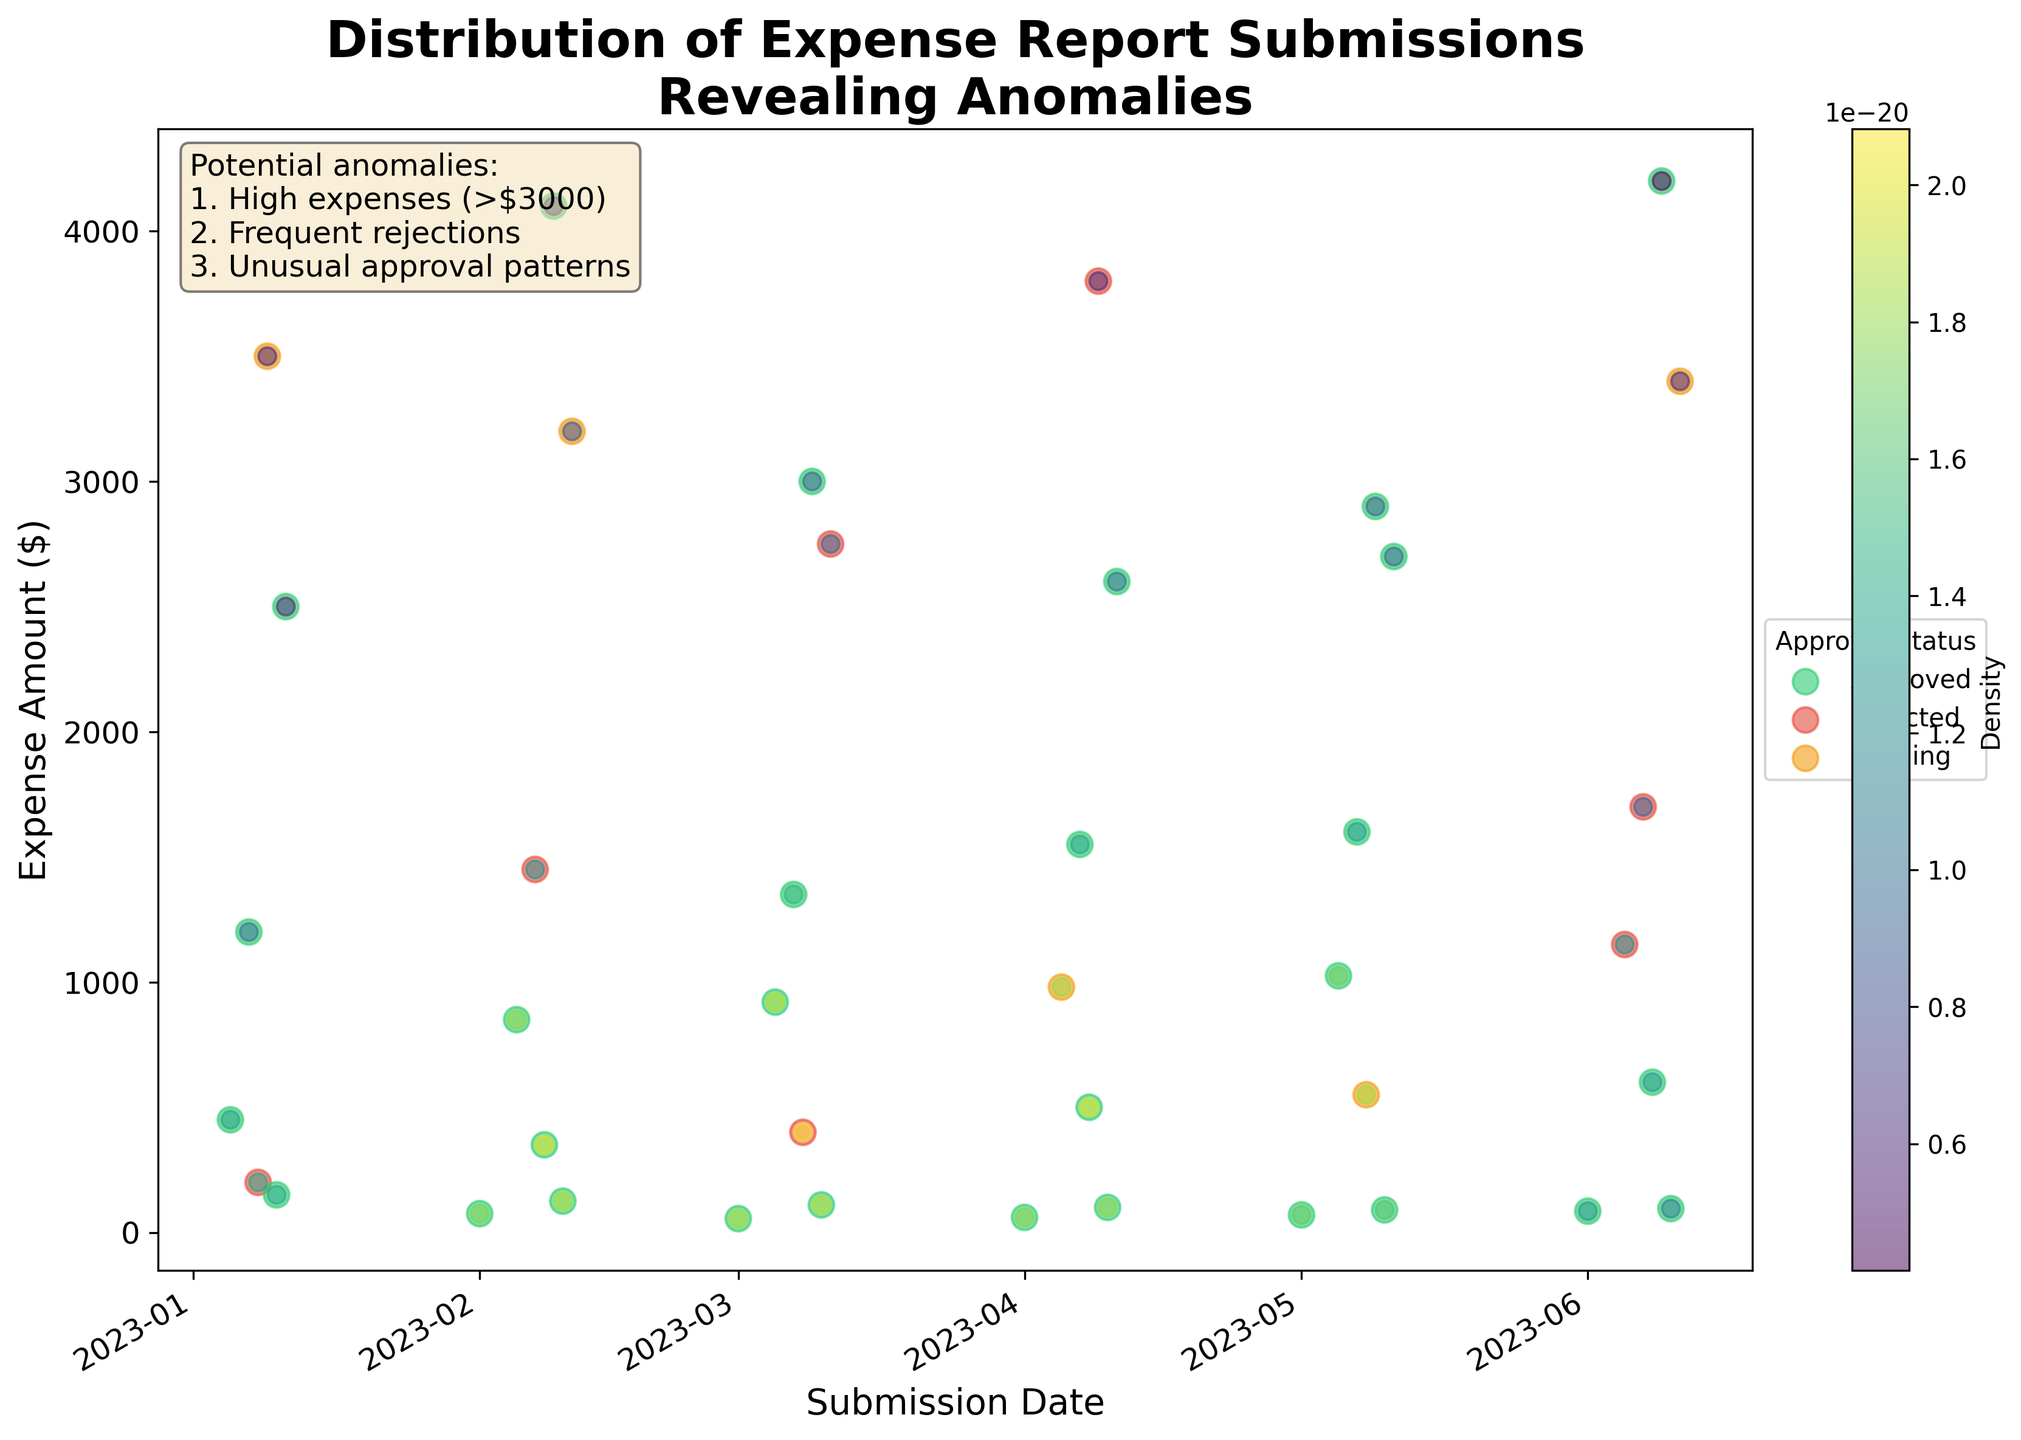What is the title of the figure? The title can be found at the top of the figure, usually in larger, bold font.
Answer: Distribution of Expense Report Submissions Revealing Anomalies What do the x-axis and y-axis represent? The labels for the x-axis and y-axis are typically located just below the x-axis and beside the y-axis, respectively. Here, the x-axis represents the 'Submission Date', and the y-axis represents the 'Expense Amount ($)'.
Answer: x-axis: Submission Date, y-axis: Expense Amount ($) What color represents "Approved" expenses? The color legend on the right side of the figure assigns colors to different approval statuses. The color for "Approved" is the same one used for the data points with the "Approved" status in the scatter plot.
Answer: Green How many data points are there for "Rejected" expenses? By referring to the color legend, we can count the number of data points that match the color assigned to "Rejected".
Answer: 7 Which date had the highest density of expense submissions? Density is represented by the color intensity of the scatter plot. The densest region will appear as the most saturated (brightest) color.
Answer: June 9, 2023 Are there more "Pending" or "Rejected" expense reports? By comparing the number of data points colored according to the legends of "Pending" and "Rejected", we can determine which has more occurrences.
Answer: Rejected What is the range of the expense amounts with the highest density of submissions? The highest density can be identified by the color gradient. The range can be determined based on where these high-density points fall on the y-axis.
Answer: Around $2000 - $4000 Describe the general trend of expense report submissions by date. Observing the scatter plot, one can identify whether the submissions are evenly spread, increasing, or decreasing over time.
Answer: There is no clear increasing or decreasing trend; submissions are relatively evenly spread over time Are there any potential anomalies mentioned in the plot? A text box in the plot lists specific potential anomalies to look for.
Answer: Yes, high expenses (>$3000), frequent rejections, unusual approval patterns What was the approximate date and expense amount for the rejected submission with the highest value? To find this, locate the highest point on the y-axis that is colored according to the "Rejected" status.
Answer: Around June 11, 2023, and $2750 